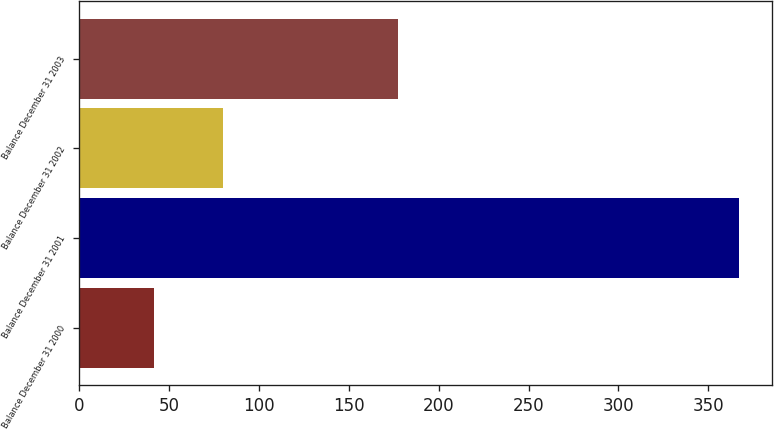<chart> <loc_0><loc_0><loc_500><loc_500><bar_chart><fcel>Balance December 31 2000<fcel>Balance December 31 2001<fcel>Balance December 31 2002<fcel>Balance December 31 2003<nl><fcel>41.5<fcel>366.9<fcel>79.7<fcel>177.6<nl></chart> 